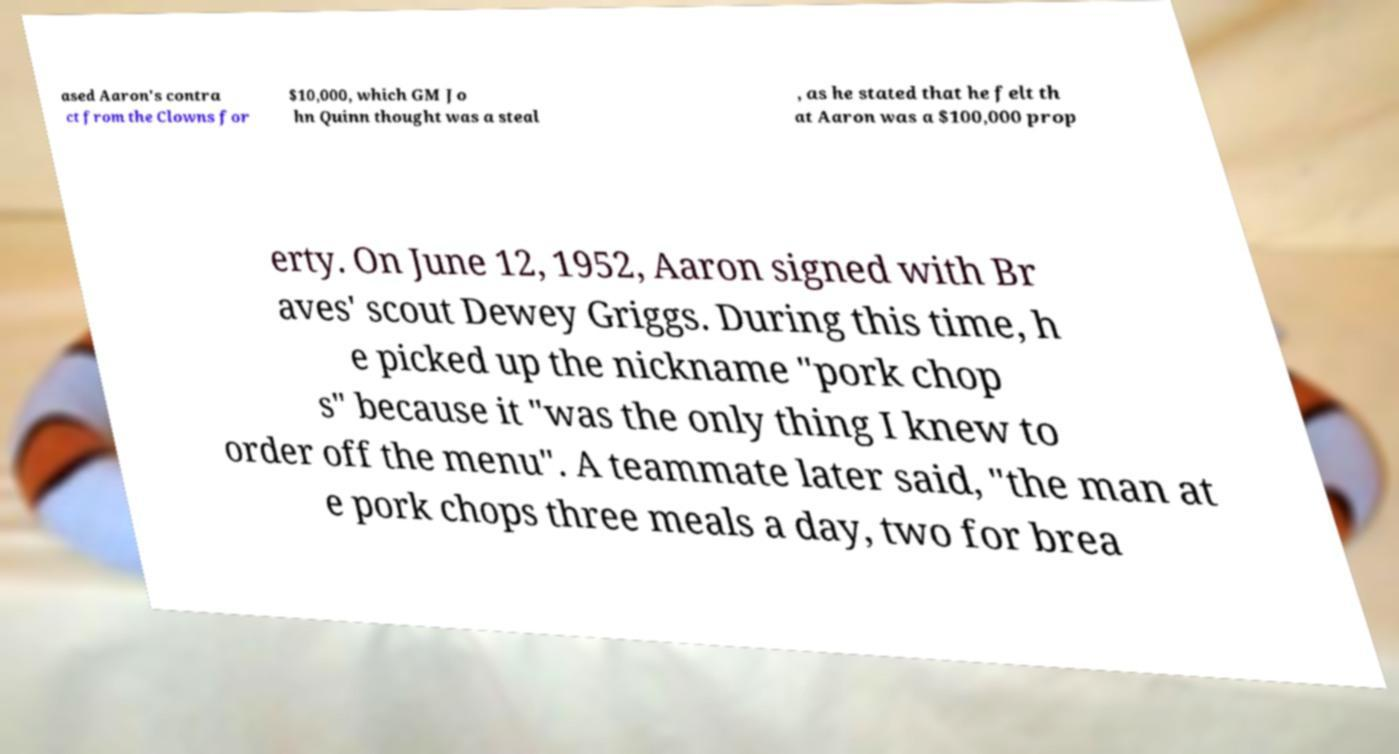Could you assist in decoding the text presented in this image and type it out clearly? ased Aaron's contra ct from the Clowns for $10,000, which GM Jo hn Quinn thought was a steal , as he stated that he felt th at Aaron was a $100,000 prop erty. On June 12, 1952, Aaron signed with Br aves' scout Dewey Griggs. During this time, h e picked up the nickname "pork chop s" because it "was the only thing I knew to order off the menu". A teammate later said, "the man at e pork chops three meals a day, two for brea 